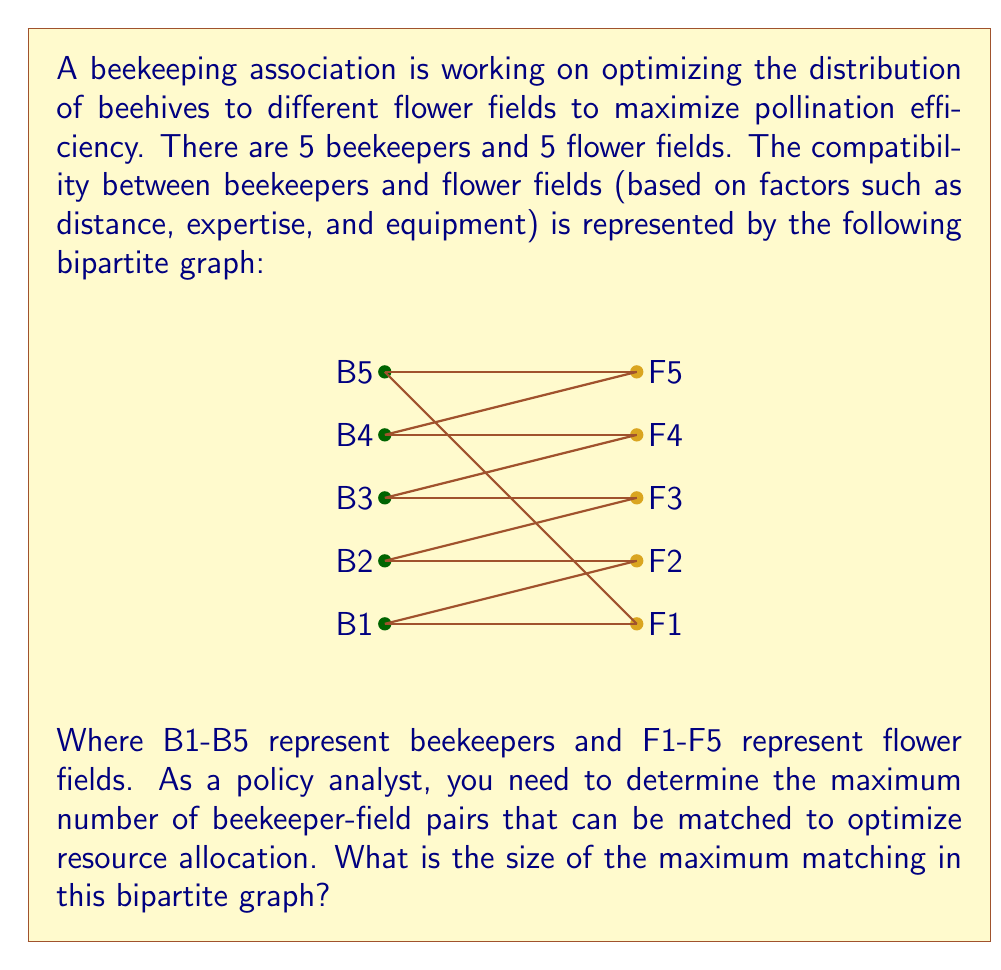Can you solve this math problem? To find the maximum matching in this bipartite graph, we can use the augmenting path algorithm:

1) Start with an empty matching M = {}.

2) Look for an augmenting path:
   - Start with B1: B1 - F1 - B4 - F4 - B3 - F3 - B2 - F2
   This is an augmenting path. Add it to M.
   M = {(B1,F1), (B4,F4), (B3,F3), (B2,F2)}

3) Look for another augmenting path:
   - Start with B5: B5 - F5
   This is an augmenting path. Add it to M.
   M = {(B1,F1), (B4,F4), (B3,F3), (B2,F2), (B5,F5)}

4) Try to find another augmenting path:
   - Start with any unmatched vertex (there are none)
   No augmenting path found.

5) The algorithm terminates. The maximum matching has been found.

The maximum matching M contains 5 edges, which means 5 beekeeper-field pairs can be optimally matched.

This result indicates that all beekeepers can be assigned to compatible flower fields, maximizing the potential for efficient pollination and optimal resource allocation.
Answer: 5 